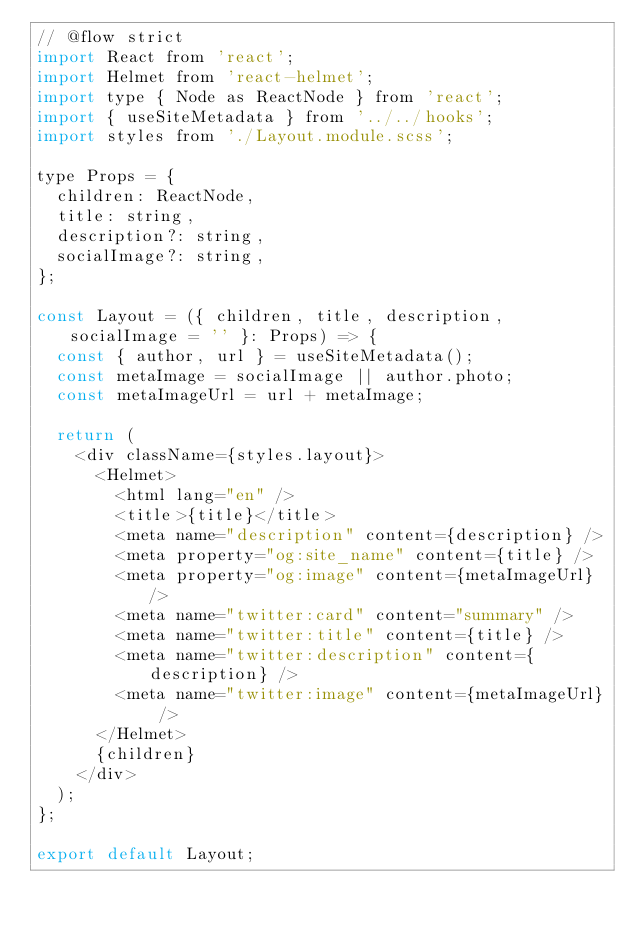<code> <loc_0><loc_0><loc_500><loc_500><_JavaScript_>// @flow strict
import React from 'react';
import Helmet from 'react-helmet';
import type { Node as ReactNode } from 'react';
import { useSiteMetadata } from '../../hooks';
import styles from './Layout.module.scss';

type Props = {
  children: ReactNode,
  title: string,
  description?: string,
  socialImage?: string,
};

const Layout = ({ children, title, description, socialImage = '' }: Props) => {
  const { author, url } = useSiteMetadata();
  const metaImage = socialImage || author.photo;
  const metaImageUrl = url + metaImage;

  return (
    <div className={styles.layout}>
      <Helmet>
        <html lang="en" />
        <title>{title}</title>
        <meta name="description" content={description} />
        <meta property="og:site_name" content={title} />
        <meta property="og:image" content={metaImageUrl} />
        <meta name="twitter:card" content="summary" />
        <meta name="twitter:title" content={title} />
        <meta name="twitter:description" content={description} />
        <meta name="twitter:image" content={metaImageUrl} />
      </Helmet>
      {children}
    </div>
  );
};

export default Layout;
</code> 